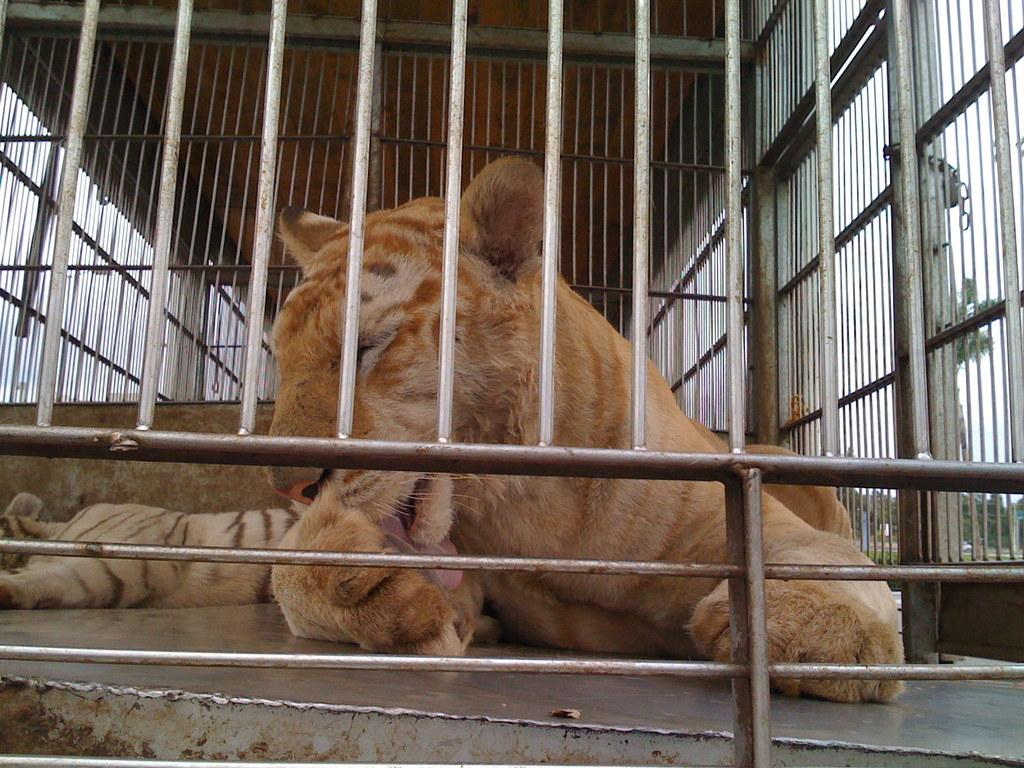What type of animals are in the image? There are tigers in the image. Where are the tigers located? The tigers are in a cage. What type of cloud can be seen in the image? There is no cloud present in the image; it features tigers in a cage. What type of legal advice can be given to the tigers in the image? There are no tigers or lawyers present in the image, so it is not possible to provide legal advice. 